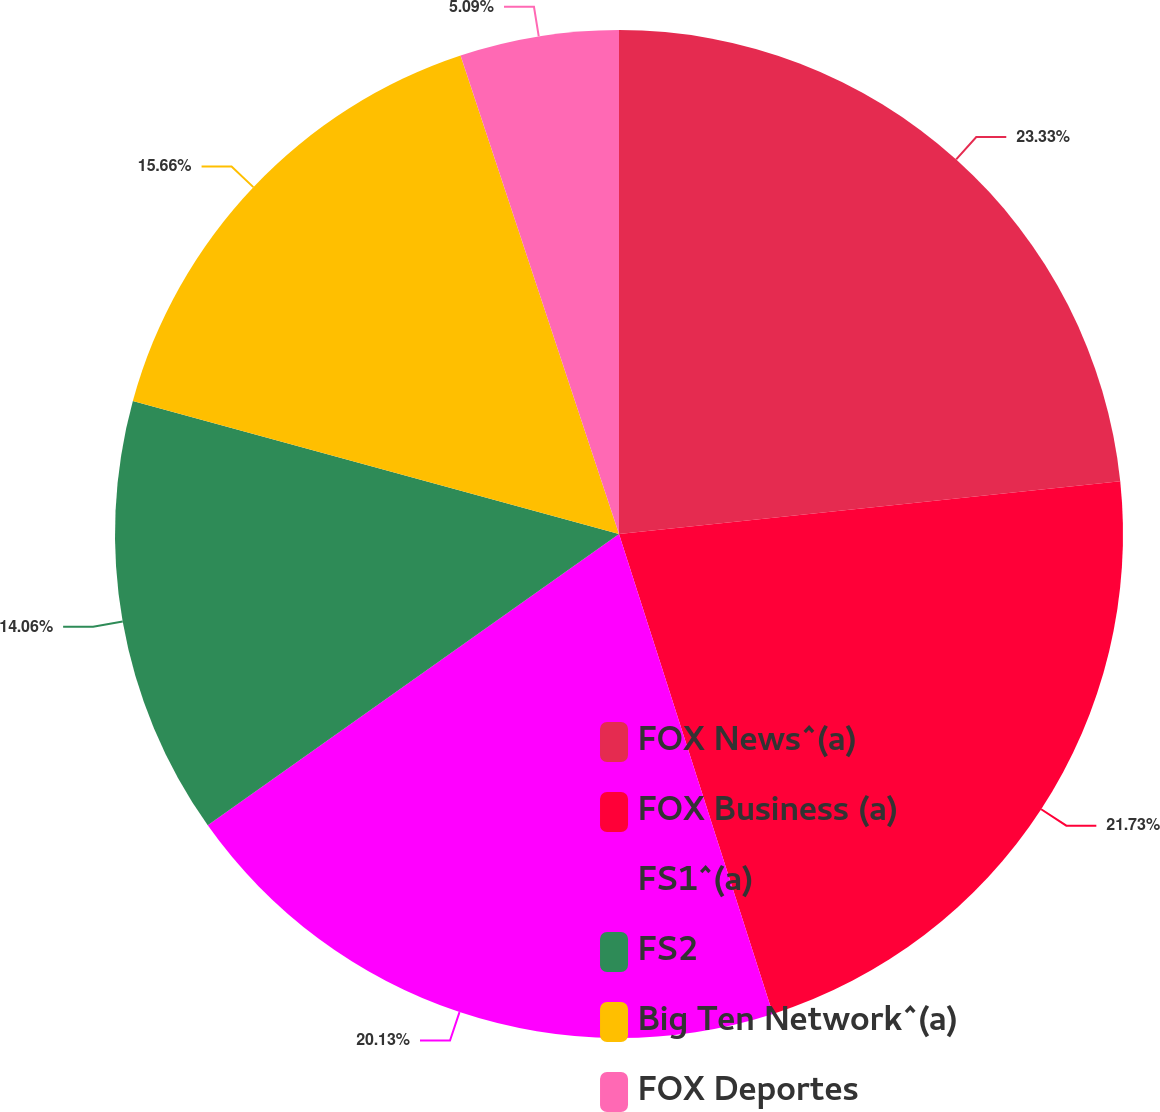<chart> <loc_0><loc_0><loc_500><loc_500><pie_chart><fcel>FOX News^(a)<fcel>FOX Business (a)<fcel>FS1^(a)<fcel>FS2<fcel>Big Ten Network^(a)<fcel>FOX Deportes<nl><fcel>23.33%<fcel>21.73%<fcel>20.13%<fcel>14.06%<fcel>15.66%<fcel>5.09%<nl></chart> 